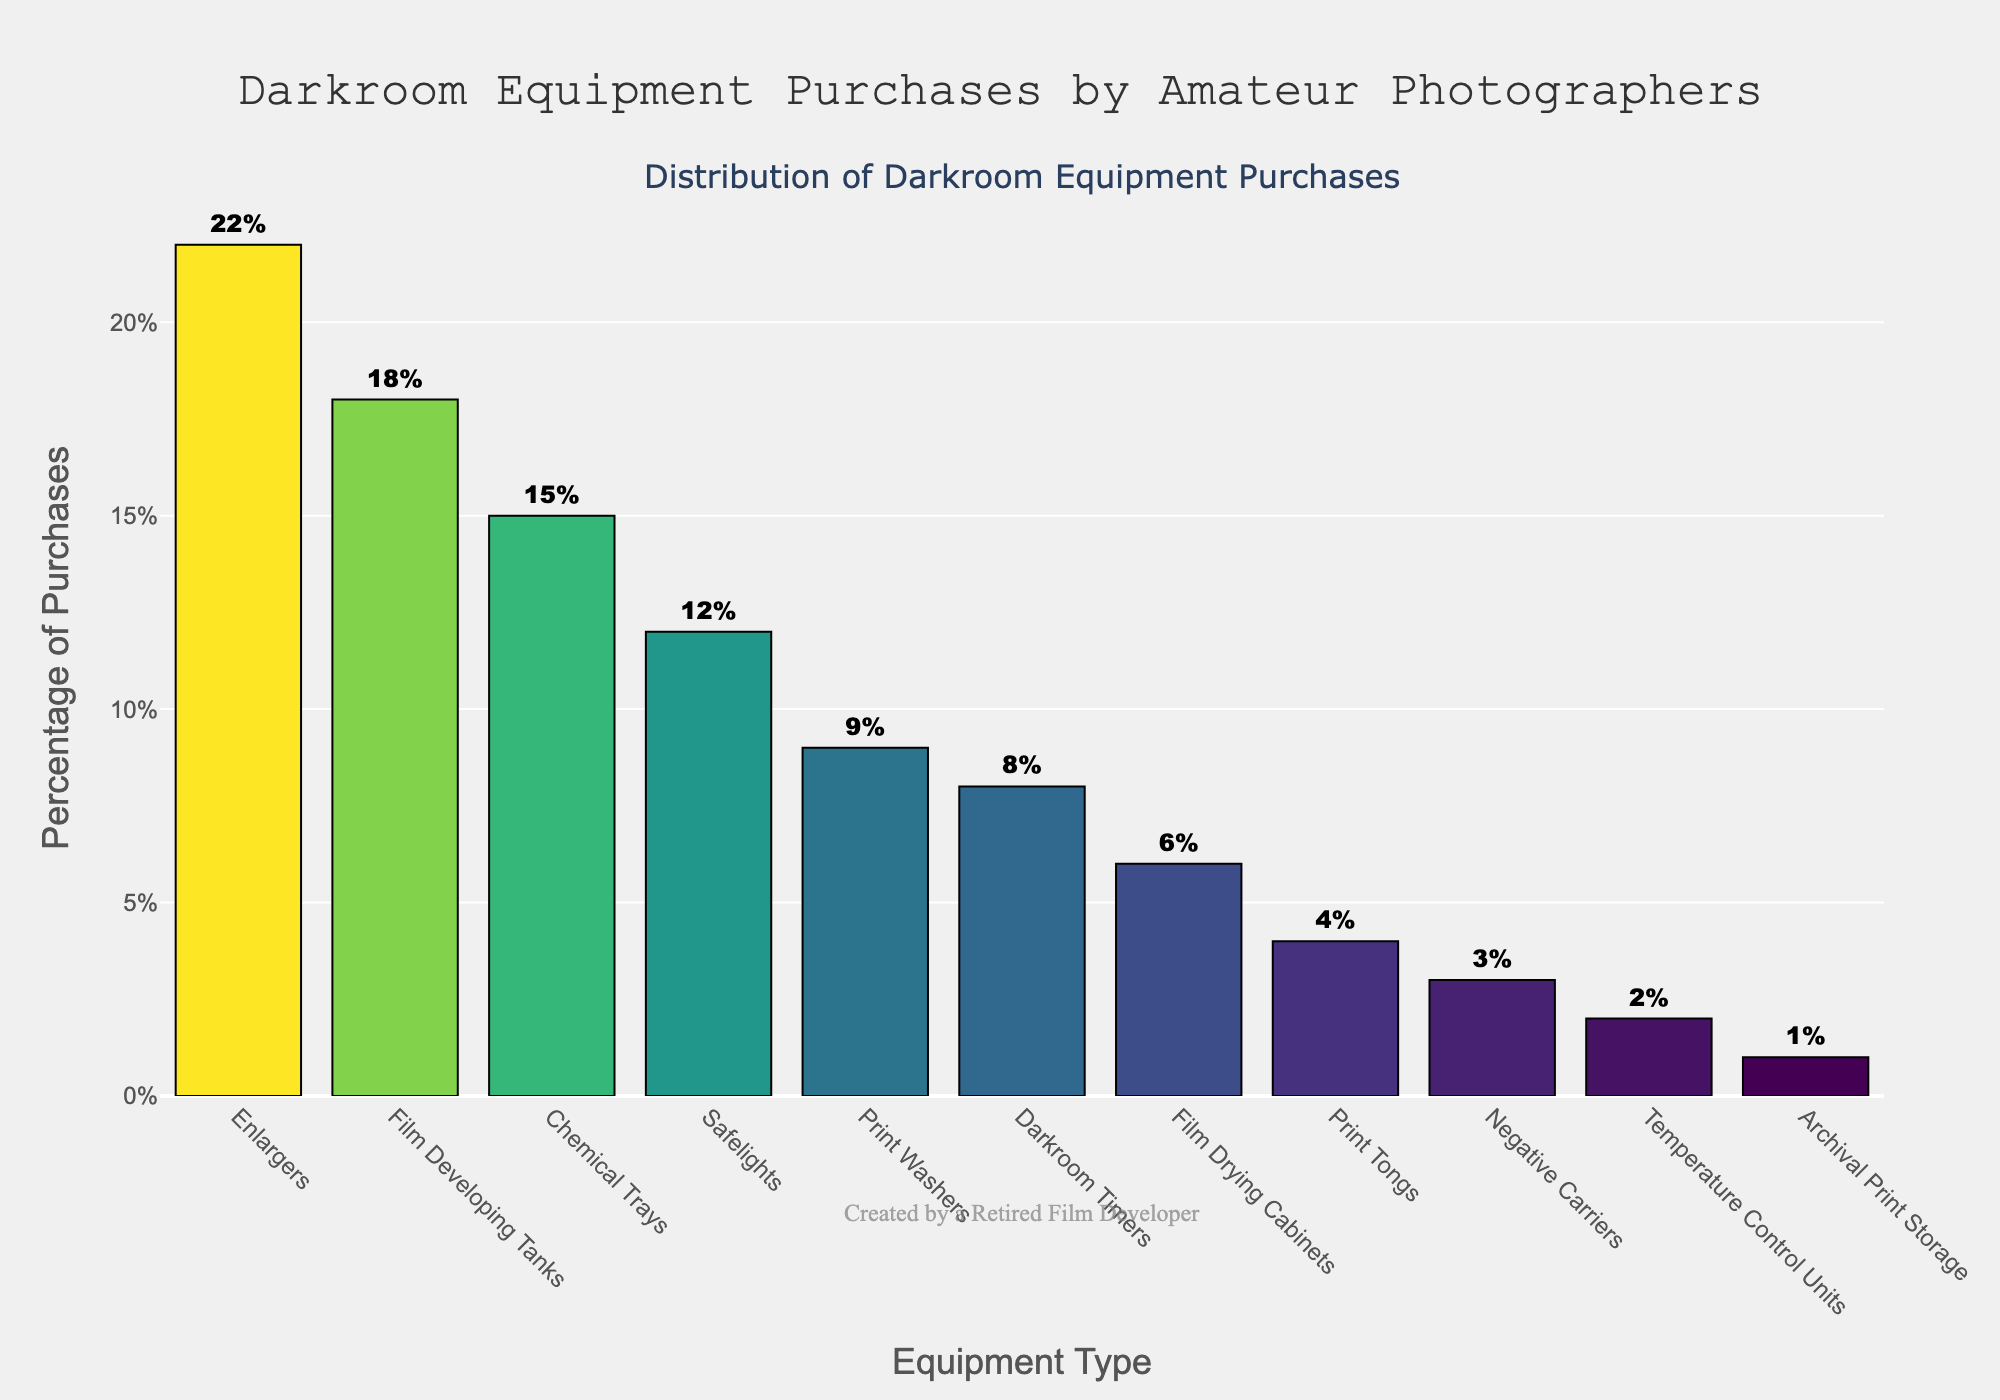Which equipment type has the highest percentage of purchases? Enlargers have the highest bar in the chart, reaching 22%
Answer: Enlargers What is the total percentage of purchases for Film Developing Tanks and Chemical Trays combined? Film Developing Tanks are at 18% and Chemical Trays are at 15%, so 18% + 15% = 33%
Answer: 33% Which equipment type has a purchase percentage less than 5%? The bars for Print Tongs, Negative Carriers, Temperature Control Units, and Archival Print Storage are all below 5%
Answer: Print Tongs, Negative Carriers, Temperature Control Units, Archival Print Storage How much greater is the percentage of purchases for Safelights than for Print Washers? The percentage for Safelights is 12% and for Print Washers is 9%, so the difference is 12% - 9% = 3%
Answer: 3% What is the average percentage of purchases for Enlargers, Film Developing Tanks, and Chemical Trays? The percentages are 22% for Enlargers, 18% for Film Developing Tanks, and 15% for Chemical Trays; (22% + 18% + 15%) / 3 = 55% / 3 ≈ 18.33%
Answer: 18.33% Which equipment type has the smallest percentage of purchases? The bar for Archival Print Storage is the smallest, at 1%
Answer: Archival Print Storage Compare the combined percentage of purchases for Print Washers and Darkroom Timers with that of Enlargers. Print Washers are at 9% and Darkroom Timers at 8%, combined they are 9% + 8% = 17%, which is less than the 22% for Enlargers
Answer: Less than What is the percentage difference between the highest and lowest purchase categories? Enlargers have the highest at 22% and Archival Print Storage has the lowest at 1%, so 22% - 1% = 21%
Answer: 21% How many equipment types have a purchase percentage of at least 10%? Enlargers, Film Developing Tanks, and Safelights each have a bar height of at least 10%, totaling 3 types
Answer: 3 What is the median purchase percentage across all equipment types? There are 11 equipment types. When ordered from highest to lowest: 22%, 18%, 15%, 12%, 9%, 8%, 6%, 4%, 3%, 2%, 1%. The middle value (6th value) is the median, which is 8%
Answer: 8% 